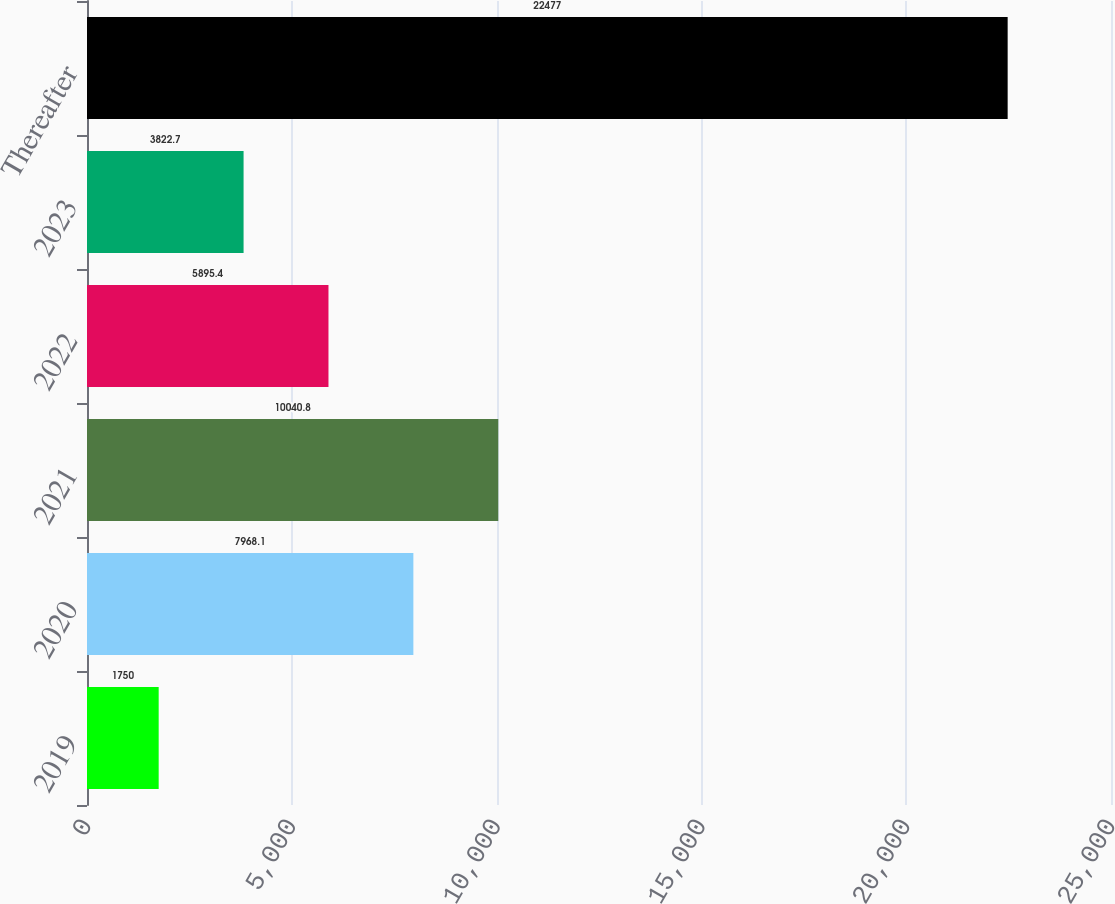Convert chart to OTSL. <chart><loc_0><loc_0><loc_500><loc_500><bar_chart><fcel>2019<fcel>2020<fcel>2021<fcel>2022<fcel>2023<fcel>Thereafter<nl><fcel>1750<fcel>7968.1<fcel>10040.8<fcel>5895.4<fcel>3822.7<fcel>22477<nl></chart> 